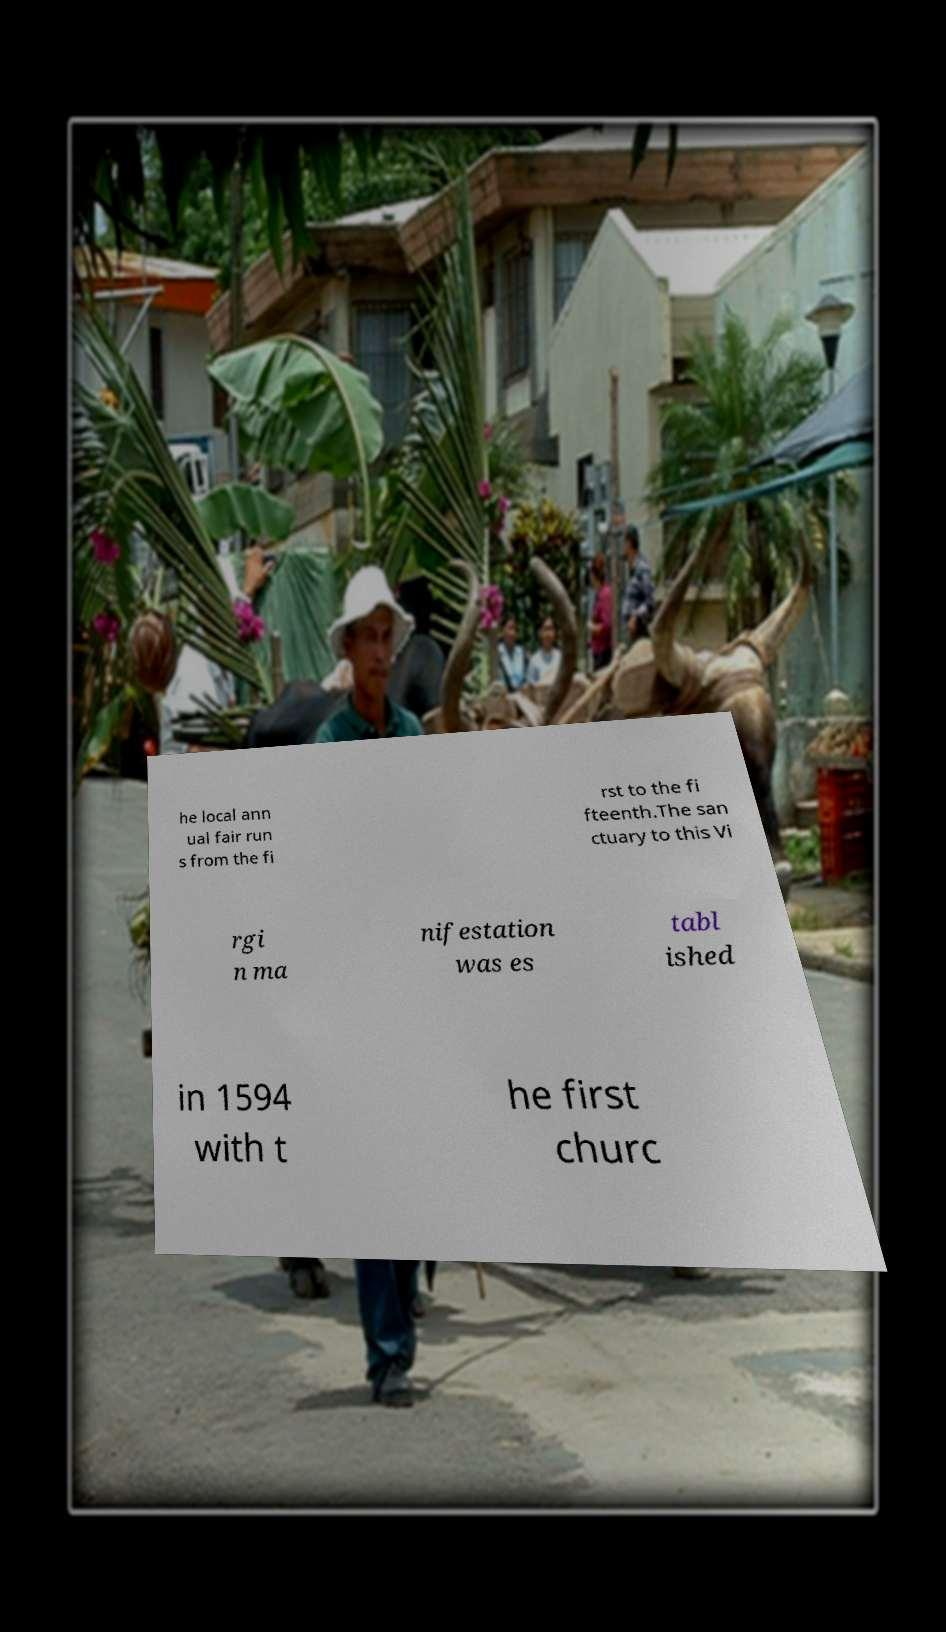Please identify and transcribe the text found in this image. he local ann ual fair run s from the fi rst to the fi fteenth.The san ctuary to this Vi rgi n ma nifestation was es tabl ished in 1594 with t he first churc 